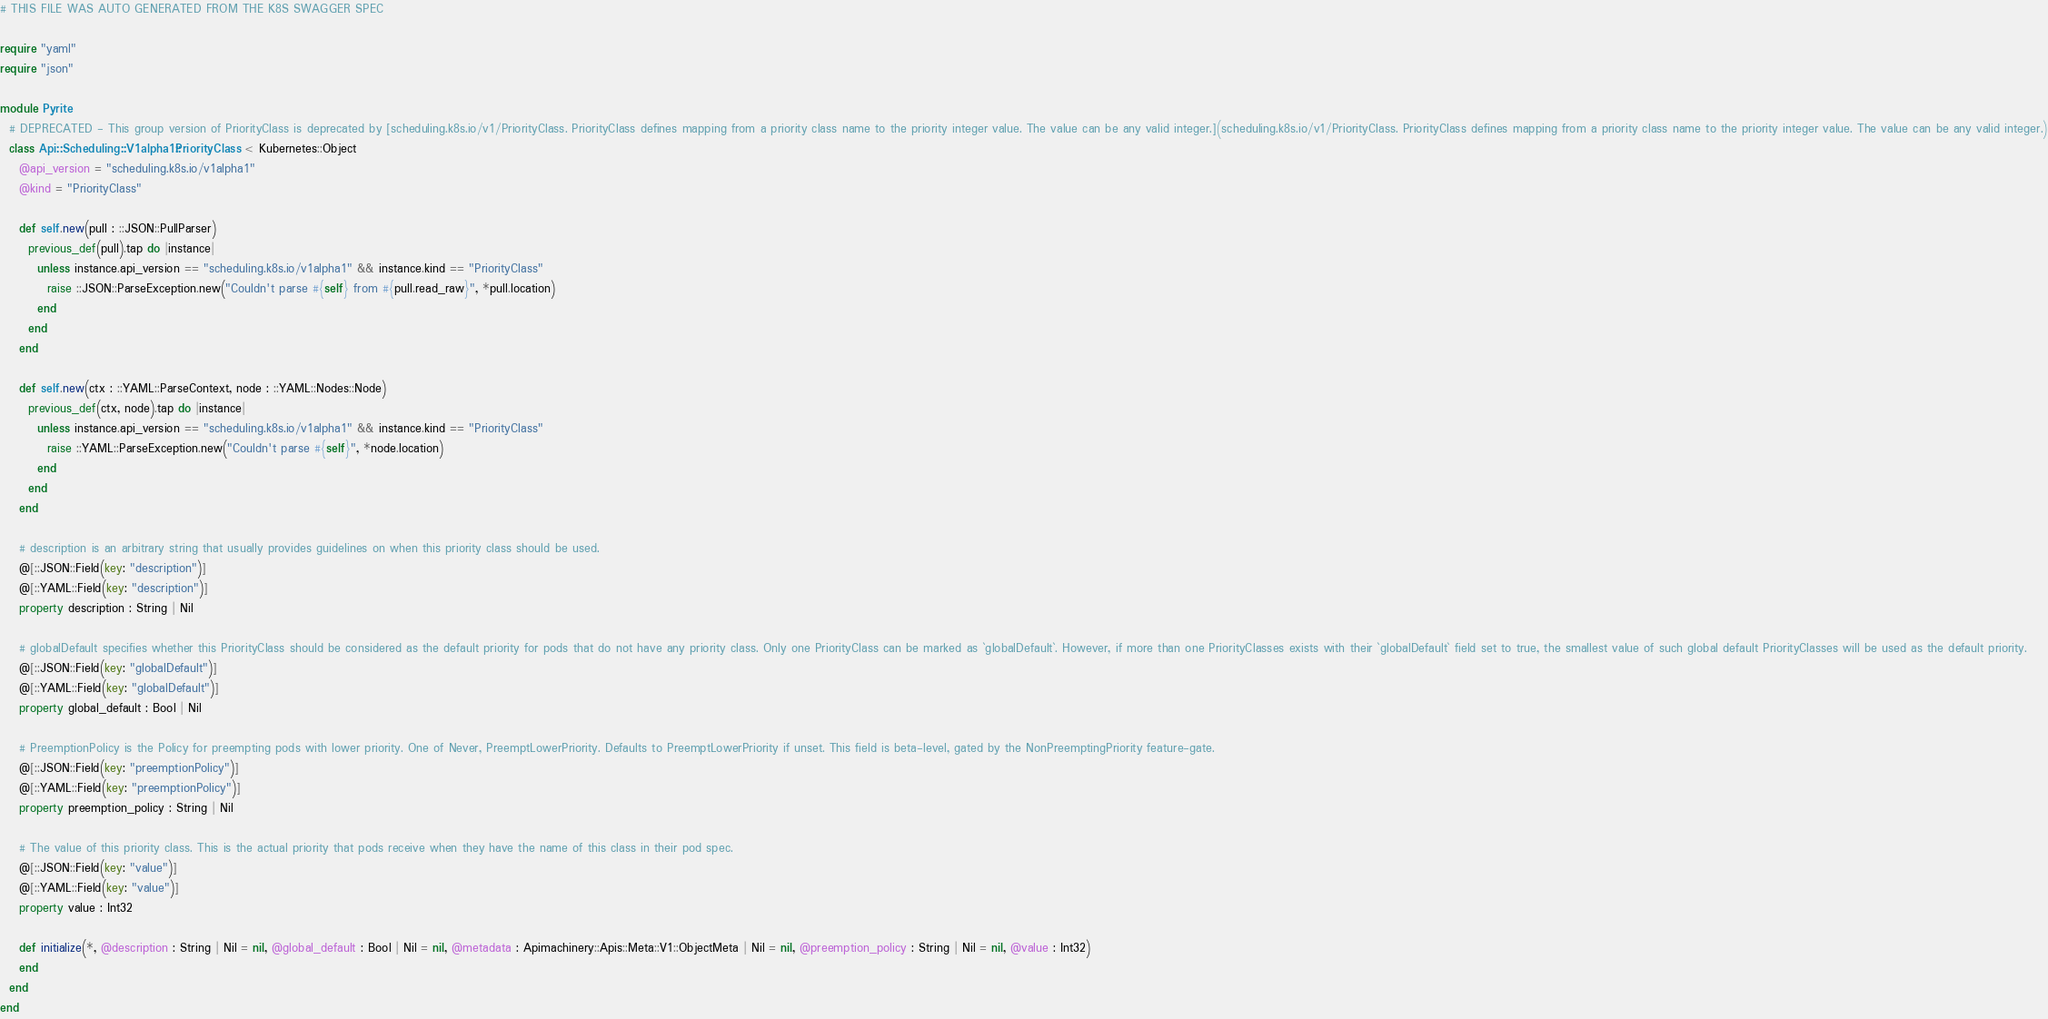<code> <loc_0><loc_0><loc_500><loc_500><_Crystal_># THIS FILE WAS AUTO GENERATED FROM THE K8S SWAGGER SPEC

require "yaml"
require "json"

module Pyrite
  # DEPRECATED - This group version of PriorityClass is deprecated by [scheduling.k8s.io/v1/PriorityClass. PriorityClass defines mapping from a priority class name to the priority integer value. The value can be any valid integer.](scheduling.k8s.io/v1/PriorityClass. PriorityClass defines mapping from a priority class name to the priority integer value. The value can be any valid integer.)
  class Api::Scheduling::V1alpha1::PriorityClass < Kubernetes::Object
    @api_version = "scheduling.k8s.io/v1alpha1"
    @kind = "PriorityClass"

    def self.new(pull : ::JSON::PullParser)
      previous_def(pull).tap do |instance|
        unless instance.api_version == "scheduling.k8s.io/v1alpha1" && instance.kind == "PriorityClass"
          raise ::JSON::ParseException.new("Couldn't parse #{self} from #{pull.read_raw}", *pull.location)
        end
      end
    end

    def self.new(ctx : ::YAML::ParseContext, node : ::YAML::Nodes::Node)
      previous_def(ctx, node).tap do |instance|
        unless instance.api_version == "scheduling.k8s.io/v1alpha1" && instance.kind == "PriorityClass"
          raise ::YAML::ParseException.new("Couldn't parse #{self}", *node.location)
        end
      end
    end

    # description is an arbitrary string that usually provides guidelines on when this priority class should be used.
    @[::JSON::Field(key: "description")]
    @[::YAML::Field(key: "description")]
    property description : String | Nil

    # globalDefault specifies whether this PriorityClass should be considered as the default priority for pods that do not have any priority class. Only one PriorityClass can be marked as `globalDefault`. However, if more than one PriorityClasses exists with their `globalDefault` field set to true, the smallest value of such global default PriorityClasses will be used as the default priority.
    @[::JSON::Field(key: "globalDefault")]
    @[::YAML::Field(key: "globalDefault")]
    property global_default : Bool | Nil

    # PreemptionPolicy is the Policy for preempting pods with lower priority. One of Never, PreemptLowerPriority. Defaults to PreemptLowerPriority if unset. This field is beta-level, gated by the NonPreemptingPriority feature-gate.
    @[::JSON::Field(key: "preemptionPolicy")]
    @[::YAML::Field(key: "preemptionPolicy")]
    property preemption_policy : String | Nil

    # The value of this priority class. This is the actual priority that pods receive when they have the name of this class in their pod spec.
    @[::JSON::Field(key: "value")]
    @[::YAML::Field(key: "value")]
    property value : Int32

    def initialize(*, @description : String | Nil = nil, @global_default : Bool | Nil = nil, @metadata : Apimachinery::Apis::Meta::V1::ObjectMeta | Nil = nil, @preemption_policy : String | Nil = nil, @value : Int32)
    end
  end
end
</code> 